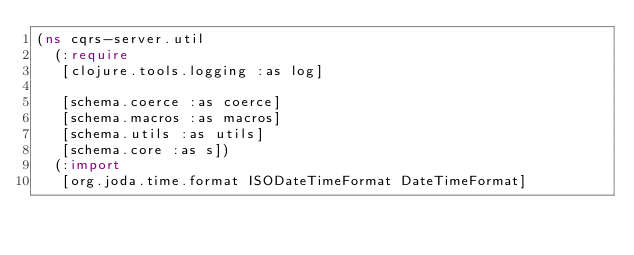Convert code to text. <code><loc_0><loc_0><loc_500><loc_500><_Clojure_>(ns cqrs-server.util
  (:require
   [clojure.tools.logging :as log]
   
   [schema.coerce :as coerce]
   [schema.macros :as macros]
   [schema.utils :as utils]
   [schema.core :as s])
  (:import
   [org.joda.time.format ISODateTimeFormat DateTimeFormat]</code> 